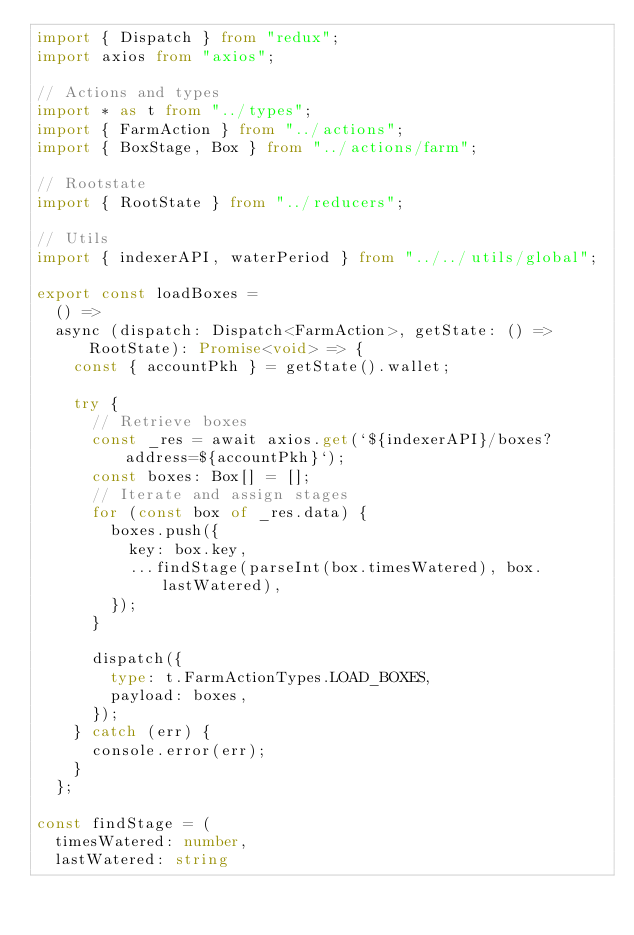<code> <loc_0><loc_0><loc_500><loc_500><_TypeScript_>import { Dispatch } from "redux";
import axios from "axios";

// Actions and types
import * as t from "../types";
import { FarmAction } from "../actions";
import { BoxStage, Box } from "../actions/farm";

// Rootstate
import { RootState } from "../reducers";

// Utils
import { indexerAPI, waterPeriod } from "../../utils/global";

export const loadBoxes =
  () =>
  async (dispatch: Dispatch<FarmAction>, getState: () => RootState): Promise<void> => {
    const { accountPkh } = getState().wallet;

    try {
      // Retrieve boxes
      const _res = await axios.get(`${indexerAPI}/boxes?address=${accountPkh}`);
      const boxes: Box[] = [];
      // Iterate and assign stages
      for (const box of _res.data) {
        boxes.push({
          key: box.key,
          ...findStage(parseInt(box.timesWatered), box.lastWatered),
        });
      }

      dispatch({
        type: t.FarmActionTypes.LOAD_BOXES,
        payload: boxes,
      });
    } catch (err) {
      console.error(err);
    }
  };

const findStage = (
  timesWatered: number,
  lastWatered: string</code> 